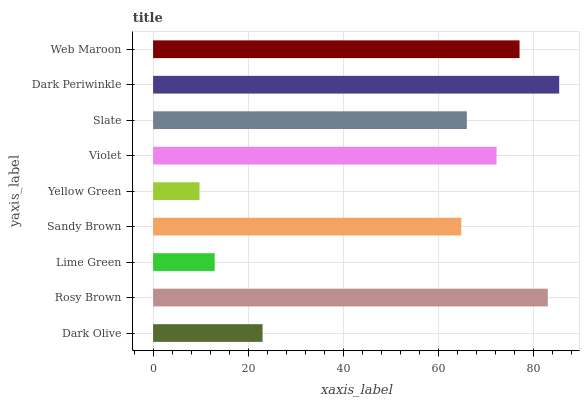Is Yellow Green the minimum?
Answer yes or no. Yes. Is Dark Periwinkle the maximum?
Answer yes or no. Yes. Is Rosy Brown the minimum?
Answer yes or no. No. Is Rosy Brown the maximum?
Answer yes or no. No. Is Rosy Brown greater than Dark Olive?
Answer yes or no. Yes. Is Dark Olive less than Rosy Brown?
Answer yes or no. Yes. Is Dark Olive greater than Rosy Brown?
Answer yes or no. No. Is Rosy Brown less than Dark Olive?
Answer yes or no. No. Is Slate the high median?
Answer yes or no. Yes. Is Slate the low median?
Answer yes or no. Yes. Is Rosy Brown the high median?
Answer yes or no. No. Is Dark Periwinkle the low median?
Answer yes or no. No. 